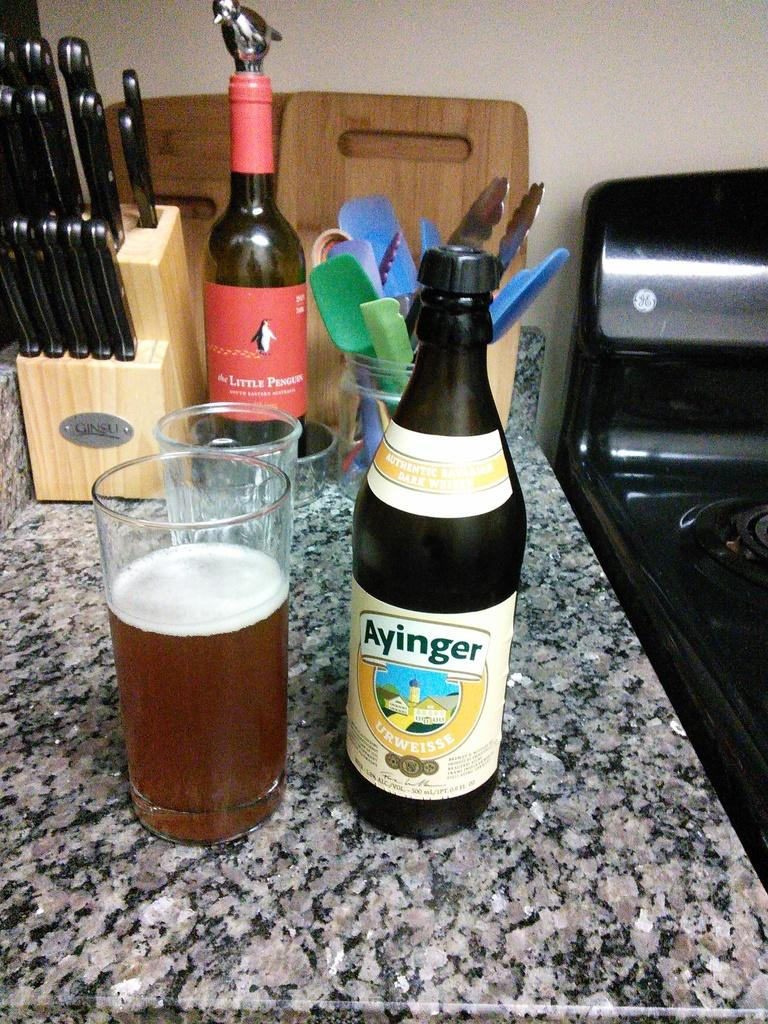<image>
Offer a succinct explanation of the picture presented. A bottle of Ayinger sits next to a glass filled with liquid. 